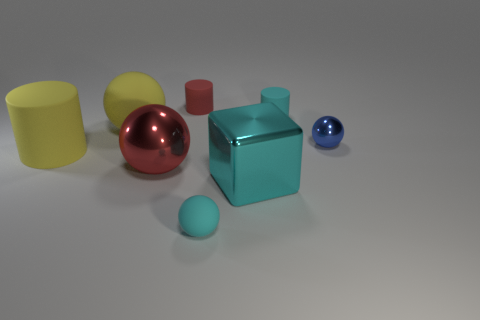What number of big red shiny things have the same shape as the cyan shiny object?
Provide a short and direct response. 0. What is the red cylinder made of?
Provide a short and direct response. Rubber. Does the red metal thing have the same shape as the small blue object?
Provide a short and direct response. Yes. Are there any yellow objects that have the same material as the yellow sphere?
Provide a succinct answer. Yes. What color is the cylinder that is both behind the blue metallic sphere and in front of the red rubber thing?
Provide a short and direct response. Cyan. What material is the small cyan thing in front of the small metallic ball?
Your answer should be compact. Rubber. Are there any cyan shiny things that have the same shape as the big red shiny thing?
Offer a very short reply. No. What number of other things are there of the same shape as the large red thing?
Give a very brief answer. 3. There is a tiny red rubber thing; is it the same shape as the yellow matte object that is in front of the small metallic ball?
Offer a terse response. Yes. There is a yellow thing that is the same shape as the large red thing; what is it made of?
Your response must be concise. Rubber. 